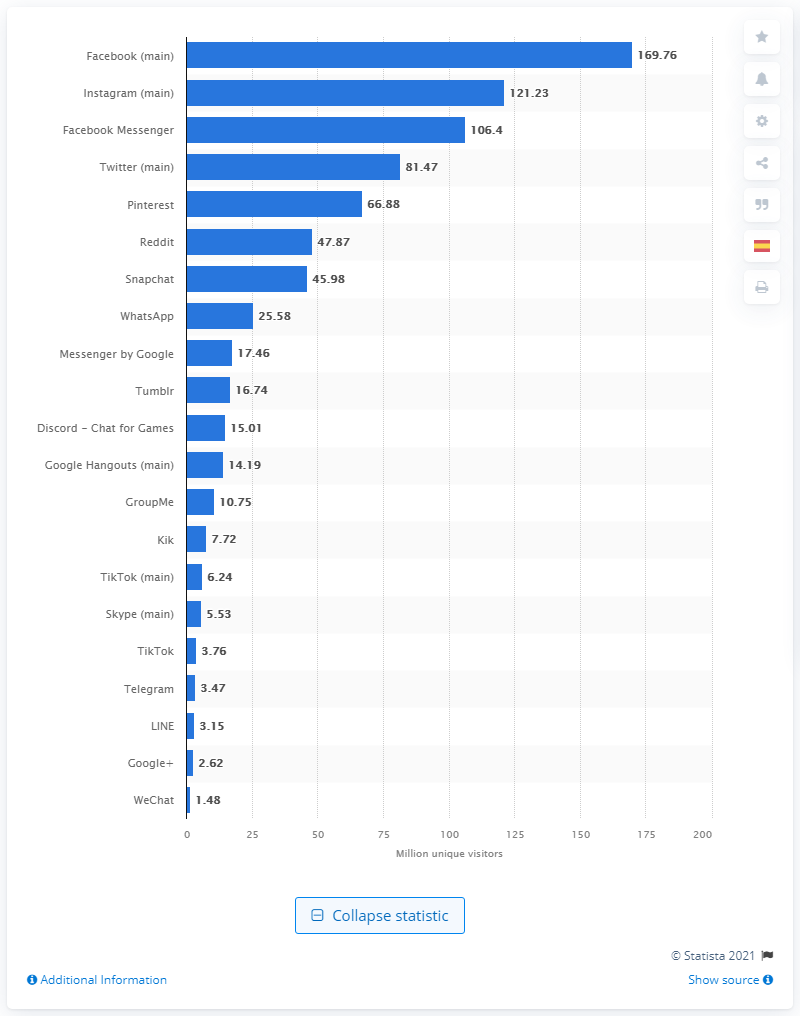Draw attention to some important aspects in this diagram. In September 2019, 169.76 people used the Facebook app. In September of 2018, the number of people who used Instagram and Facebook Messenger was 106.4. 